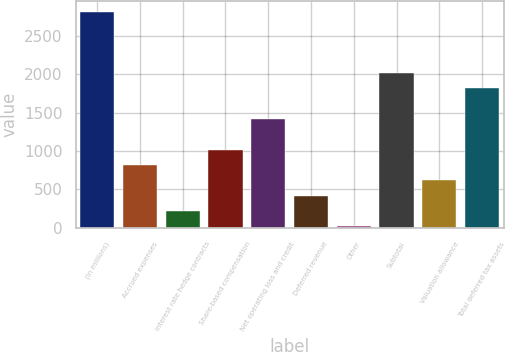Convert chart to OTSL. <chart><loc_0><loc_0><loc_500><loc_500><bar_chart><fcel>(In millions)<fcel>Accrued expenses<fcel>Interest rate hedge contracts<fcel>Share-based compensation<fcel>Net operating loss and credit<fcel>Deferred revenue<fcel>Other<fcel>Subtotal<fcel>Valuation allowance<fcel>Total deferred tax assets<nl><fcel>2816.4<fcel>815.4<fcel>215.1<fcel>1015.5<fcel>1415.7<fcel>415.2<fcel>15<fcel>2016<fcel>615.3<fcel>1815.9<nl></chart> 